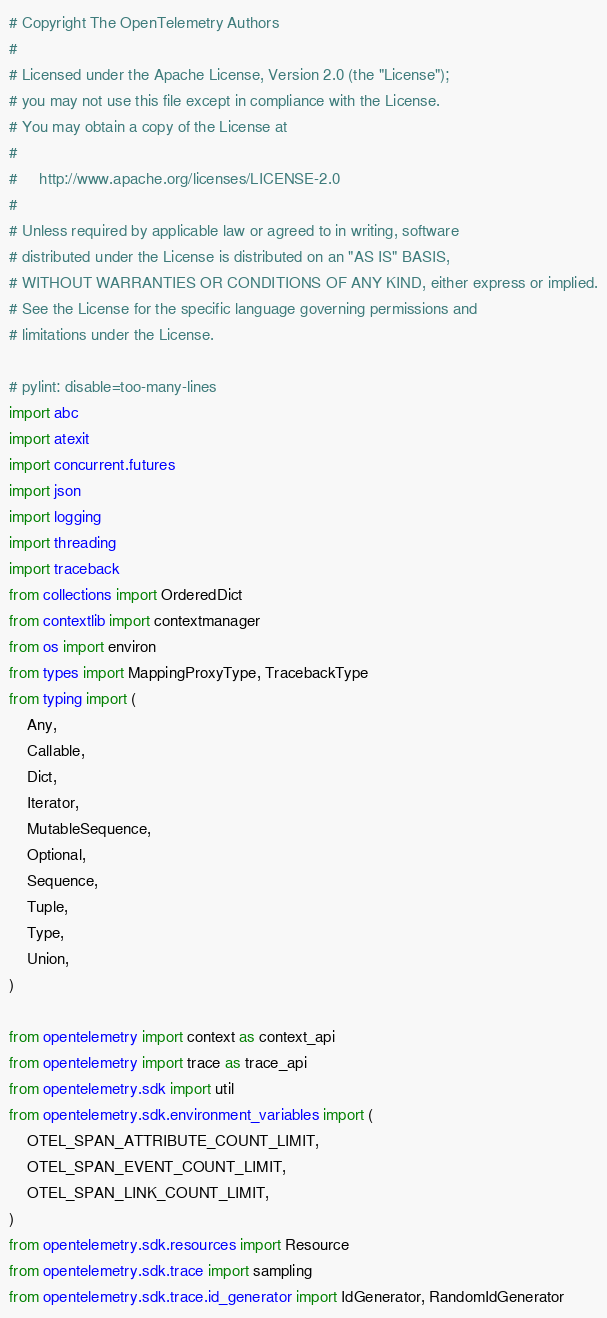Convert code to text. <code><loc_0><loc_0><loc_500><loc_500><_Python_># Copyright The OpenTelemetry Authors
#
# Licensed under the Apache License, Version 2.0 (the "License");
# you may not use this file except in compliance with the License.
# You may obtain a copy of the License at
#
#     http://www.apache.org/licenses/LICENSE-2.0
#
# Unless required by applicable law or agreed to in writing, software
# distributed under the License is distributed on an "AS IS" BASIS,
# WITHOUT WARRANTIES OR CONDITIONS OF ANY KIND, either express or implied.
# See the License for the specific language governing permissions and
# limitations under the License.

# pylint: disable=too-many-lines
import abc
import atexit
import concurrent.futures
import json
import logging
import threading
import traceback
from collections import OrderedDict
from contextlib import contextmanager
from os import environ
from types import MappingProxyType, TracebackType
from typing import (
    Any,
    Callable,
    Dict,
    Iterator,
    MutableSequence,
    Optional,
    Sequence,
    Tuple,
    Type,
    Union,
)

from opentelemetry import context as context_api
from opentelemetry import trace as trace_api
from opentelemetry.sdk import util
from opentelemetry.sdk.environment_variables import (
    OTEL_SPAN_ATTRIBUTE_COUNT_LIMIT,
    OTEL_SPAN_EVENT_COUNT_LIMIT,
    OTEL_SPAN_LINK_COUNT_LIMIT,
)
from opentelemetry.sdk.resources import Resource
from opentelemetry.sdk.trace import sampling
from opentelemetry.sdk.trace.id_generator import IdGenerator, RandomIdGenerator</code> 